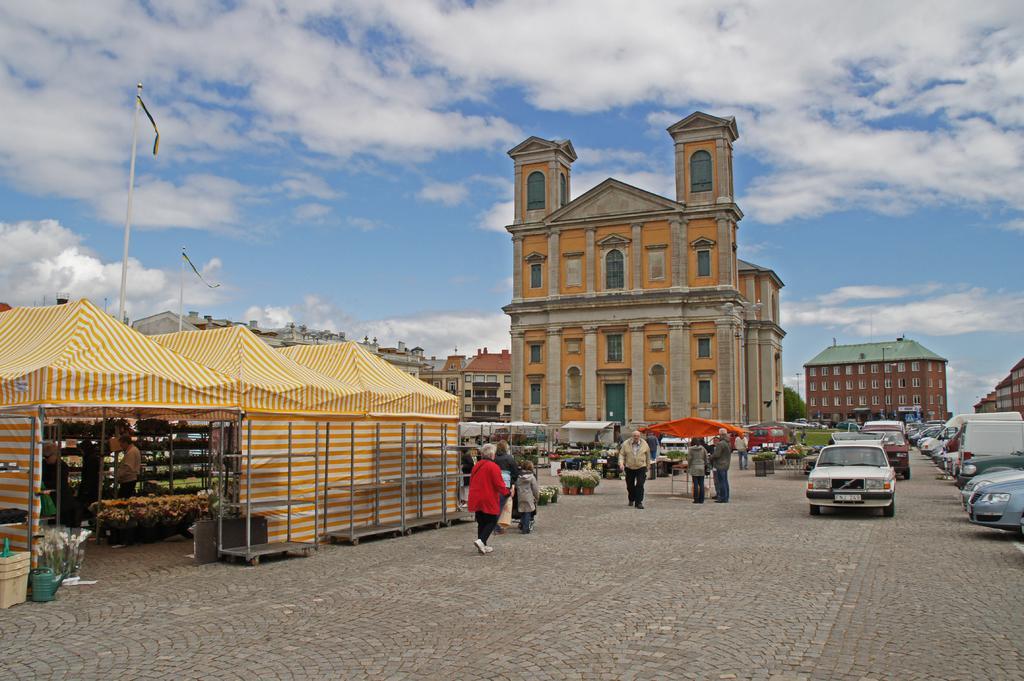How would you summarize this image in a sentence or two? In the center of the image there is a building. On the right side of the image there is a building, cars and persons. On the left side of the image there are buildings, tents and persons. In the background there is a sky and clouds. 